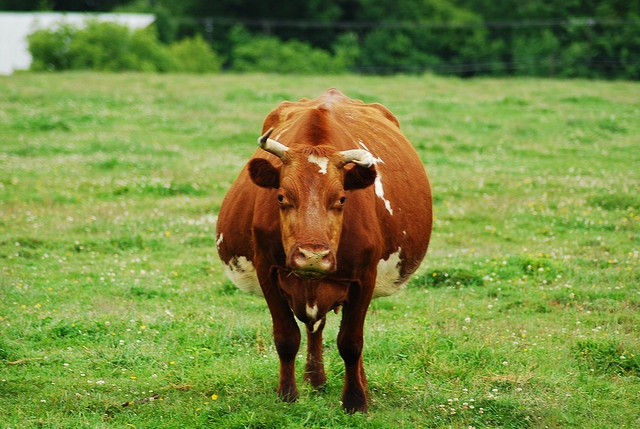Describe the objects in this image and their specific colors. I can see a cow in black, brown, maroon, and tan tones in this image. 